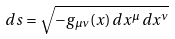Convert formula to latex. <formula><loc_0><loc_0><loc_500><loc_500>d s = { \sqrt { - g _ { \mu \nu } ( x ) \, d x ^ { \mu } \, d x ^ { \nu } } }</formula> 